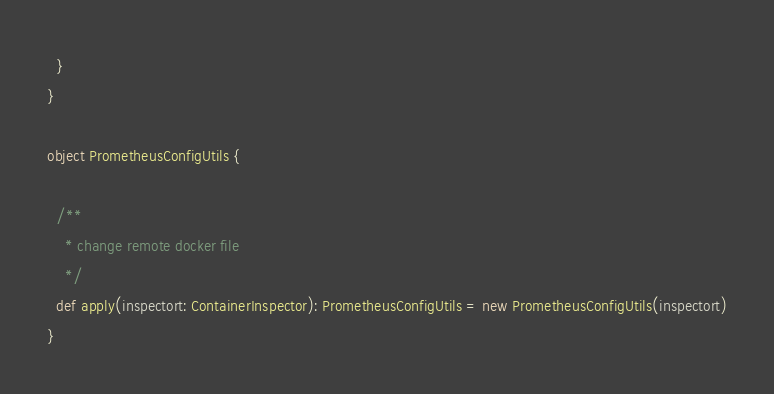Convert code to text. <code><loc_0><loc_0><loc_500><loc_500><_Scala_>  }
}

object PrometheusConfigUtils {

  /**
    * change remote docker file
    */
  def apply(inspectort: ContainerInspector): PrometheusConfigUtils = new PrometheusConfigUtils(inspectort)
}
</code> 